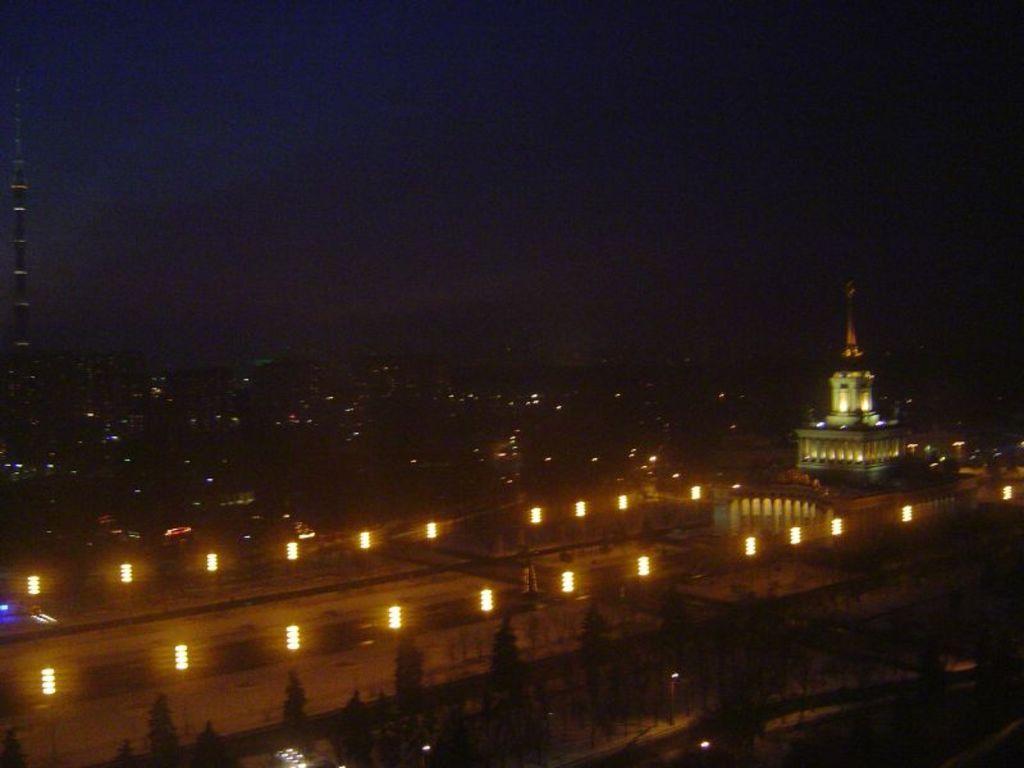Can you describe this image briefly? This picture is clicked outside. In the foreground we can see the trees, lights and many other objects. On the right there is a building. In the background we can see the sky, tower and many other buildings. 